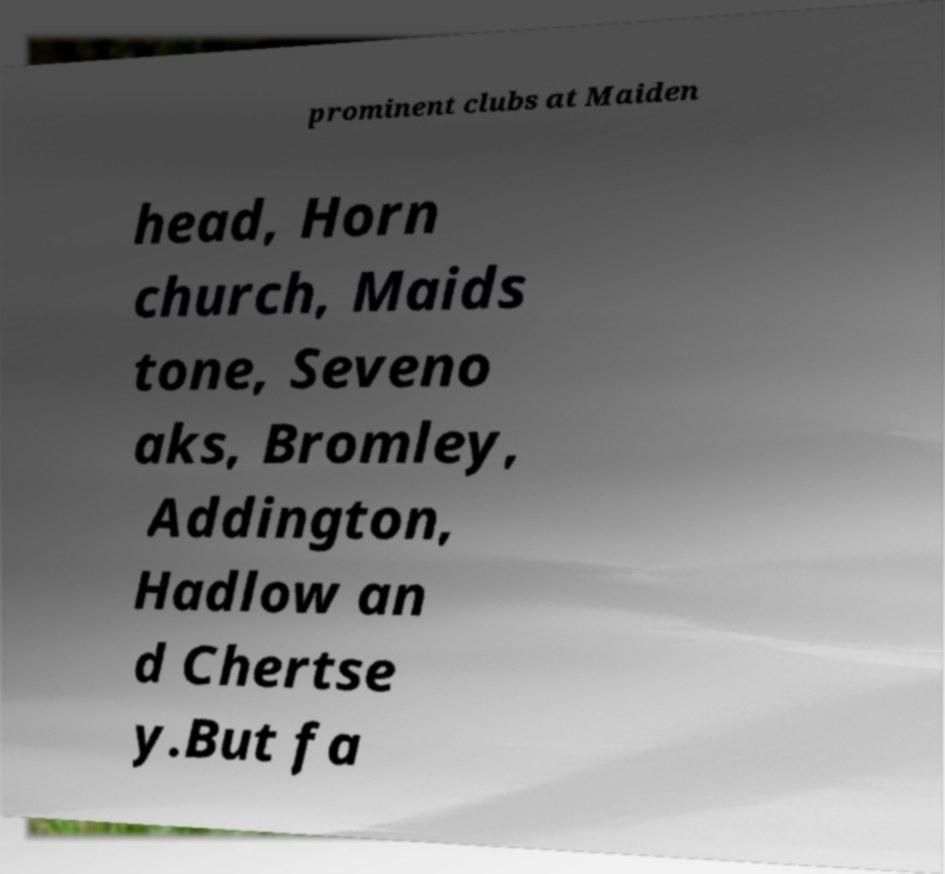Could you extract and type out the text from this image? prominent clubs at Maiden head, Horn church, Maids tone, Seveno aks, Bromley, Addington, Hadlow an d Chertse y.But fa 